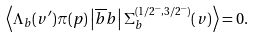Convert formula to latex. <formula><loc_0><loc_0><loc_500><loc_500>\left < \Lambda _ { b } ( v ^ { \prime } ) \pi ( p ) \left | \overline { b } b \right | \Sigma _ { b } ^ { ( 1 / 2 ^ { - } , 3 / 2 ^ { - } ) } ( v ) \right > = 0 .</formula> 